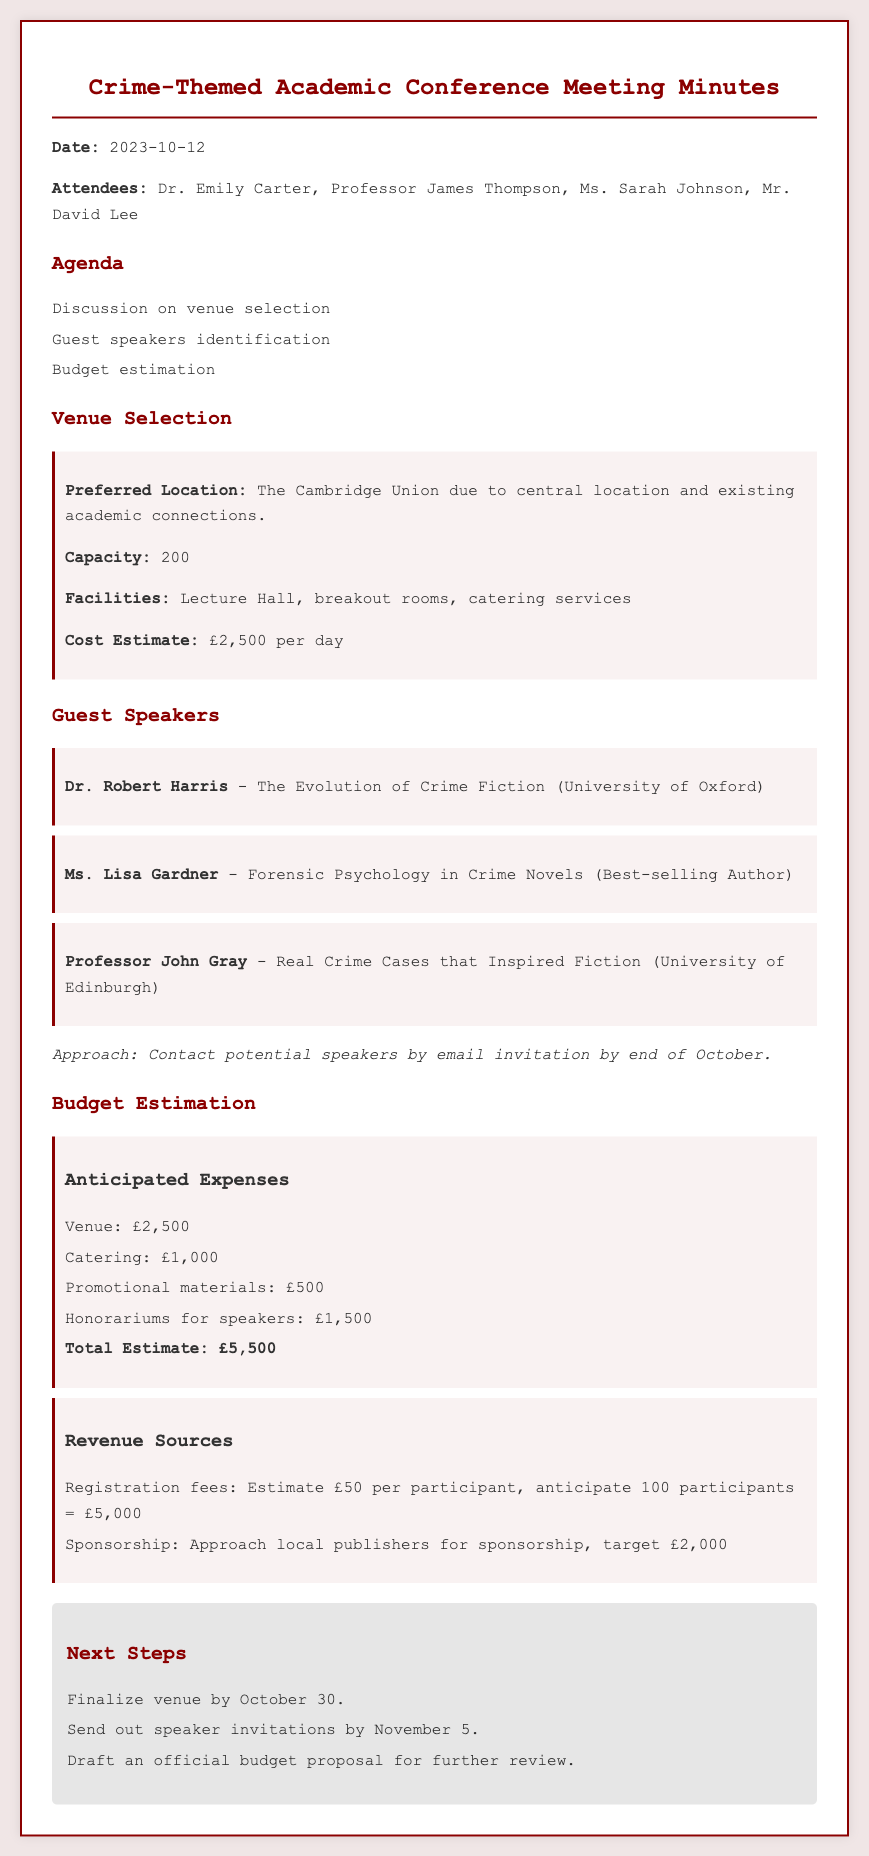What is the date of the meeting? The date of the meeting is stated at the beginning of the document.
Answer: 2023-10-12 What is the preferred venue for the conference? The preferred venue is mentioned in the venue selection section of the document.
Answer: The Cambridge Union How many participants can the venue accommodate? The capacity of the venue is provided in the venue selection section.
Answer: 200 Who is one of the guest speakers? Guest speakers are listed in the document, which mentions several names.
Answer: Dr. Robert Harris What is the total estimated expense for the conference? The total estimate is provided in the budget estimation section of the document.
Answer: £5,500 What is the anticipated revenue from registration fees? The expected revenue from registration fees can be calculated as indicated in the revenue sources section.
Answer: £5,000 By when should the venue be finalized? The next steps section includes deadlines for actions that need to be completed.
Answer: October 30 What is the honorarium amount budgeted for speakers? The budget estimation section specifies the amount allocated for speaker honorariums.
Answer: £1,500 When should speaker invitations be sent out? The deadline for sending out speaker invitations is stated in the next steps section.
Answer: November 5 